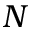Convert formula to latex. <formula><loc_0><loc_0><loc_500><loc_500>N</formula> 